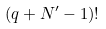Convert formula to latex. <formula><loc_0><loc_0><loc_500><loc_500>( q + N ^ { \prime } - 1 ) !</formula> 